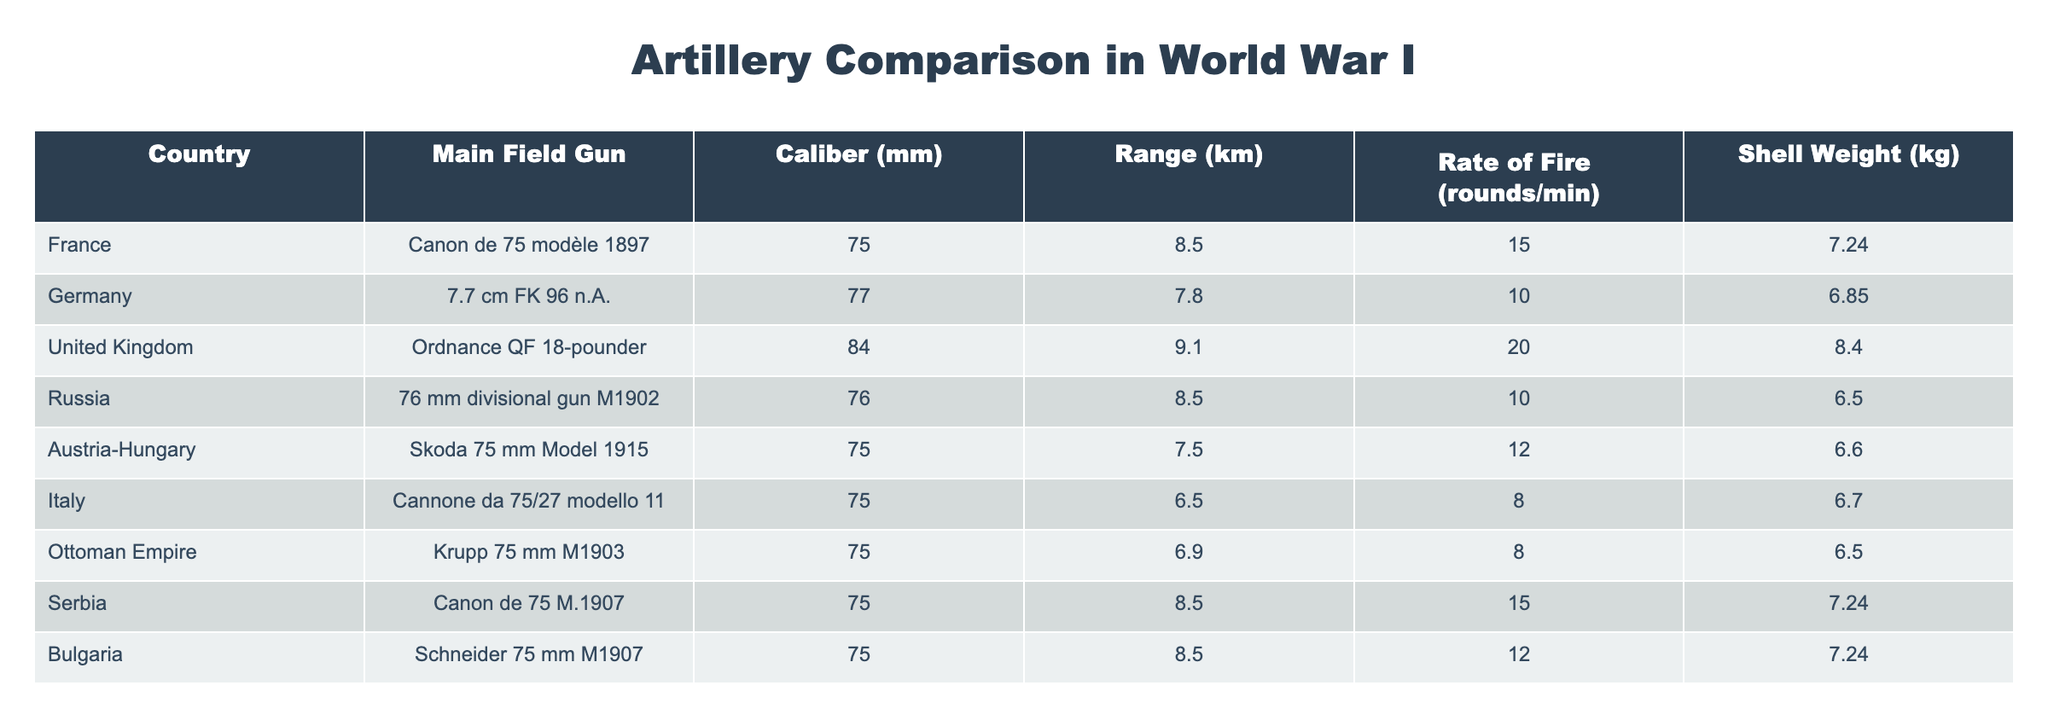What is the caliber of the United Kingdom's main field gun? The United Kingdom's main field gun listed in the table is the Ordnance QF 18-pounder, which has a caliber of 84 mm.
Answer: 84 mm Which country has the highest rate of fire? By checking the rate of fire column, the United Kingdom has the highest rate of fire at 20 rounds per minute.
Answer: 20 rounds/min Is the shell weight of the German field gun heavier than that of the Italian field gun? The shell weight of the German field gun (6.85 kg) is heavier than the Italian field gun (6.7 kg). Therefore, the statement is true.
Answer: Yes What is the average range of all the artillery listed? The ranges are: 8.5, 7.8, 9.1, 8.5, 7.5, 6.5, 6.9, 8.5, and 8.5 km. Summing these gives 63.4 km across 9 countries, thus the average range is 63.4/9 = 7.07 km.
Answer: 7.07 km How many countries have a main field gun caliber of 75 mm? From the table, the countries with a 75 mm caliber are France, Austria-Hungary, Italy, Ottoman Empire, Serbia, and Bulgaria, totaling six countries.
Answer: 6 Which artillery has the longest range, and what is that range? By reviewing the range data, the United Kingdom's Ordnance QF 18-pounder has the longest range of 9.1 km.
Answer: 9.1 km What is the difference in shell weight between the French and the German field guns? The shell weight of the French gun is 7.24 kg and the German's is 6.85 kg. The difference is 7.24 - 6.85 = 0.39 kg.
Answer: 0.39 kg Does any country have the same caliber as the Ottoman Empire's field gun? The Ottoman Empire's field gun has a caliber of 75 mm, which is also the caliber of the field guns for France, Austria-Hungary, Italy, Serbia, and Bulgaria. Therefore, the answer is yes.
Answer: Yes Which country has a field gun with the shortest range, and what is that range? The field gun with the shortest range is Italy's Cannone da 75/27 modello 11 at 6.5 km.
Answer: Italy, 6.5 km 